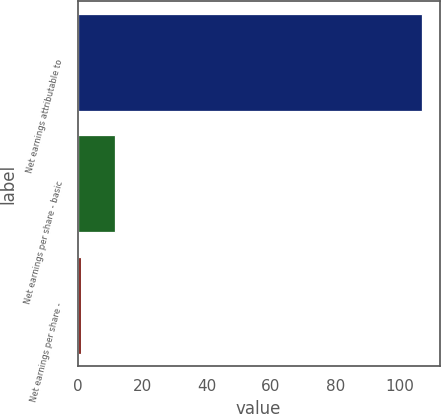<chart> <loc_0><loc_0><loc_500><loc_500><bar_chart><fcel>Net earnings attributable to<fcel>Net earnings per share - basic<fcel>Net earnings per share -<nl><fcel>107.1<fcel>11.63<fcel>1.02<nl></chart> 